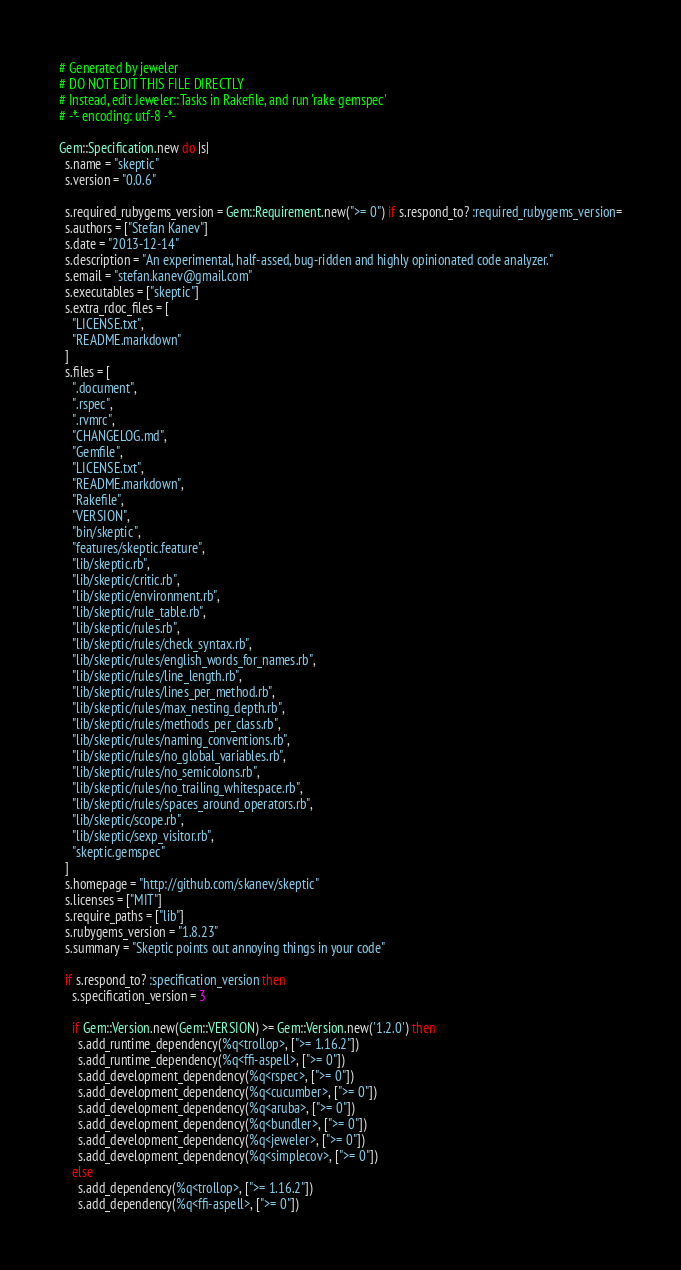<code> <loc_0><loc_0><loc_500><loc_500><_Ruby_># Generated by jeweler
# DO NOT EDIT THIS FILE DIRECTLY
# Instead, edit Jeweler::Tasks in Rakefile, and run 'rake gemspec'
# -*- encoding: utf-8 -*-

Gem::Specification.new do |s|
  s.name = "skeptic"
  s.version = "0.0.6"

  s.required_rubygems_version = Gem::Requirement.new(">= 0") if s.respond_to? :required_rubygems_version=
  s.authors = ["Stefan Kanev"]
  s.date = "2013-12-14"
  s.description = "An experimental, half-assed, bug-ridden and highly opinionated code analyzer."
  s.email = "stefan.kanev@gmail.com"
  s.executables = ["skeptic"]
  s.extra_rdoc_files = [
    "LICENSE.txt",
    "README.markdown"
  ]
  s.files = [
    ".document",
    ".rspec",
    ".rvmrc",
    "CHANGELOG.md",
    "Gemfile",
    "LICENSE.txt",
    "README.markdown",
    "Rakefile",
    "VERSION",
    "bin/skeptic",
    "features/skeptic.feature",
    "lib/skeptic.rb",
    "lib/skeptic/critic.rb",
    "lib/skeptic/environment.rb",
    "lib/skeptic/rule_table.rb",
    "lib/skeptic/rules.rb",
    "lib/skeptic/rules/check_syntax.rb",
    "lib/skeptic/rules/english_words_for_names.rb",
    "lib/skeptic/rules/line_length.rb",
    "lib/skeptic/rules/lines_per_method.rb",
    "lib/skeptic/rules/max_nesting_depth.rb",
    "lib/skeptic/rules/methods_per_class.rb",
    "lib/skeptic/rules/naming_conventions.rb",
    "lib/skeptic/rules/no_global_variables.rb",
    "lib/skeptic/rules/no_semicolons.rb",
    "lib/skeptic/rules/no_trailing_whitespace.rb",
    "lib/skeptic/rules/spaces_around_operators.rb",
    "lib/skeptic/scope.rb",
    "lib/skeptic/sexp_visitor.rb",
    "skeptic.gemspec"
  ]
  s.homepage = "http://github.com/skanev/skeptic"
  s.licenses = ["MIT"]
  s.require_paths = ["lib"]
  s.rubygems_version = "1.8.23"
  s.summary = "Skeptic points out annoying things in your code"

  if s.respond_to? :specification_version then
    s.specification_version = 3

    if Gem::Version.new(Gem::VERSION) >= Gem::Version.new('1.2.0') then
      s.add_runtime_dependency(%q<trollop>, [">= 1.16.2"])
      s.add_runtime_dependency(%q<ffi-aspell>, [">= 0"])
      s.add_development_dependency(%q<rspec>, [">= 0"])
      s.add_development_dependency(%q<cucumber>, [">= 0"])
      s.add_development_dependency(%q<aruba>, [">= 0"])
      s.add_development_dependency(%q<bundler>, [">= 0"])
      s.add_development_dependency(%q<jeweler>, [">= 0"])
      s.add_development_dependency(%q<simplecov>, [">= 0"])
    else
      s.add_dependency(%q<trollop>, [">= 1.16.2"])
      s.add_dependency(%q<ffi-aspell>, [">= 0"])</code> 